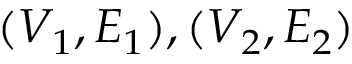<formula> <loc_0><loc_0><loc_500><loc_500>( V _ { 1 } , E _ { 1 } ) , ( V _ { 2 } , E _ { 2 } )</formula> 